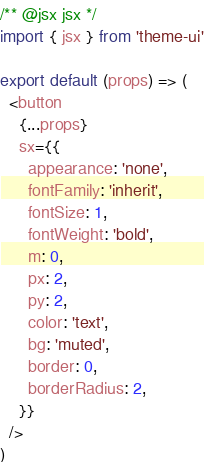Convert code to text. <code><loc_0><loc_0><loc_500><loc_500><_JavaScript_>/** @jsx jsx */
import { jsx } from 'theme-ui'

export default (props) => (
  <button
    {...props}
    sx={{
      appearance: 'none',
      fontFamily: 'inherit',
      fontSize: 1,
      fontWeight: 'bold',
      m: 0,
      px: 2,
      py: 2,
      color: 'text',
      bg: 'muted',
      border: 0,
      borderRadius: 2,
    }}
  />
)
</code> 